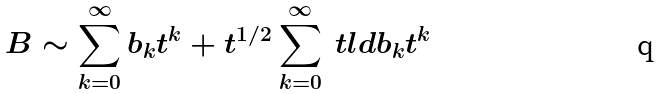Convert formula to latex. <formula><loc_0><loc_0><loc_500><loc_500>B \sim \sum _ { k = 0 } ^ { \infty } b _ { k } t ^ { k } + t ^ { 1 / 2 } \sum _ { k = 0 } ^ { \infty } \ t l d { b } _ { k } t ^ { k }</formula> 